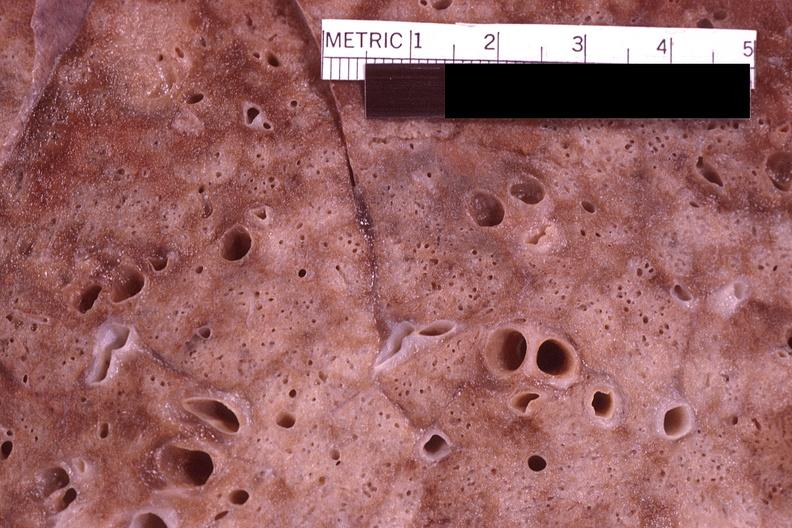what is present?
Answer the question using a single word or phrase. Respiratory 